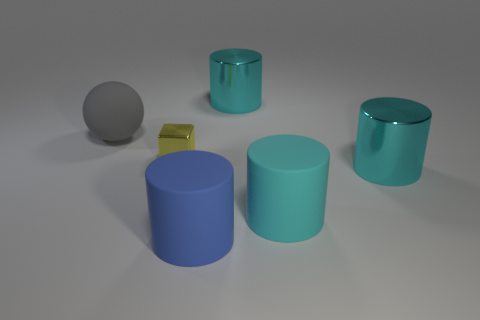What can you tell me about the lighting and shadows in the picture? The lighting in the image appears to be coming from the upper left, as evidenced by the shadows cast towards the bottom right. The shadows are soft-edged, suggesting a diffuse light source, which contributes to the calm and serene atmosphere of the scene. 